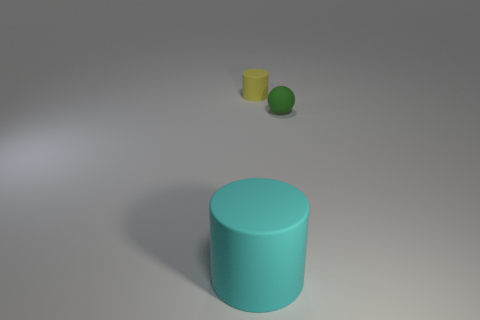Is the color of the large cylinder the same as the small matte object to the left of the small green thing? No, the large cylinder has a distinct turquoise color, while the small matte object to the left of the small green sphere appears to be a shade of yellow. Each object presents a unique hue, contributing to a colorful array within the scene. 